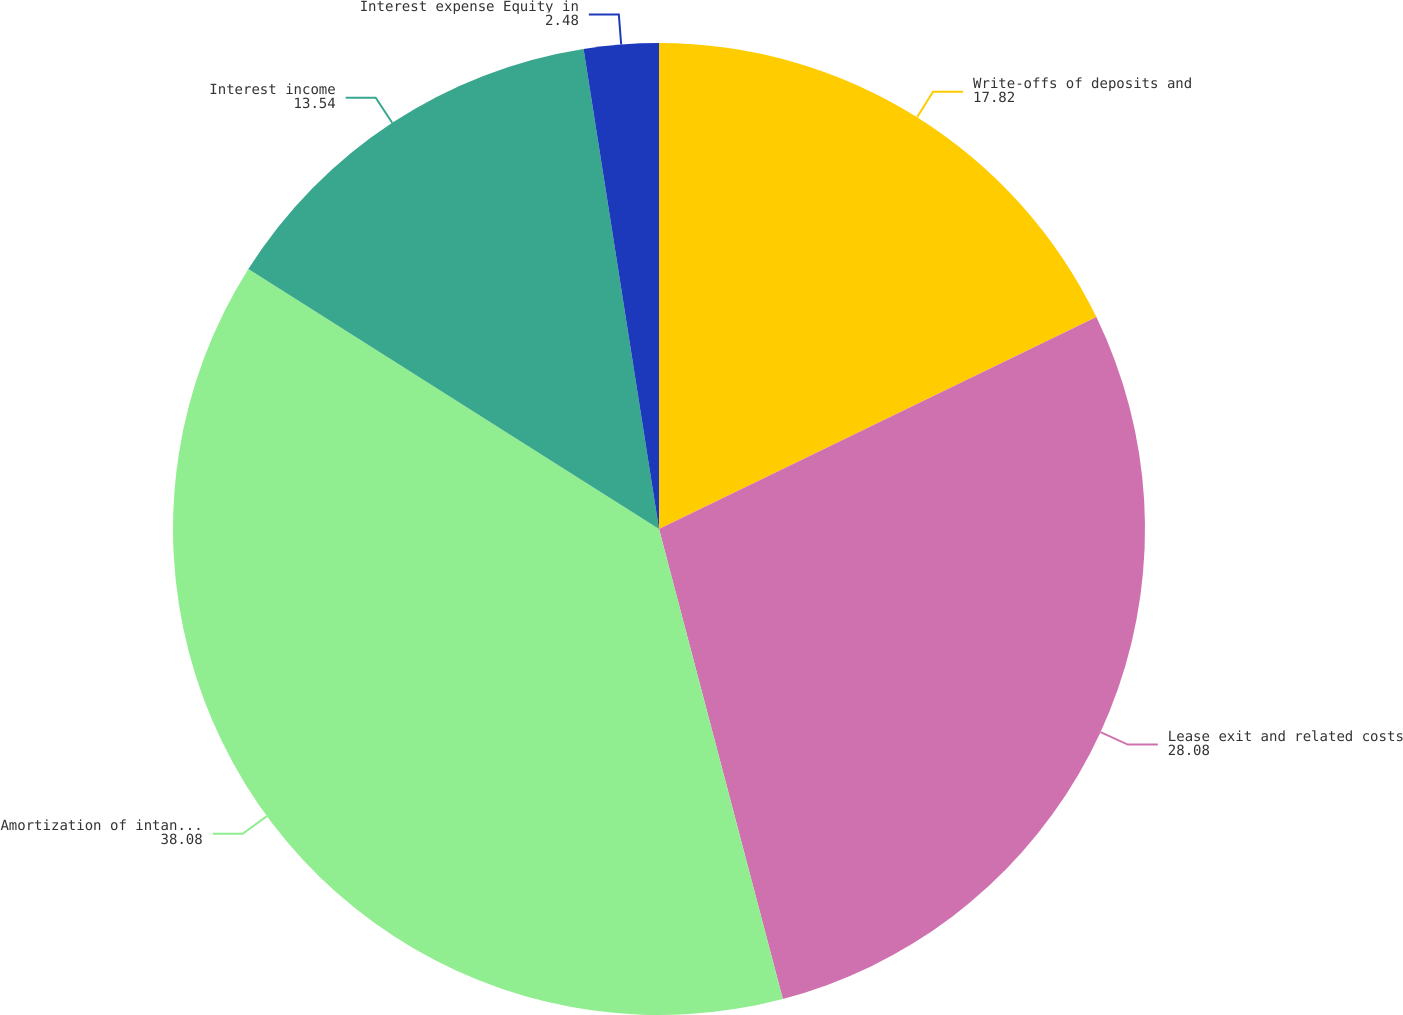Convert chart to OTSL. <chart><loc_0><loc_0><loc_500><loc_500><pie_chart><fcel>Write-offs of deposits and<fcel>Lease exit and related costs<fcel>Amortization of intangible<fcel>Interest income<fcel>Interest expense Equity in<nl><fcel>17.82%<fcel>28.08%<fcel>38.08%<fcel>13.54%<fcel>2.48%<nl></chart> 